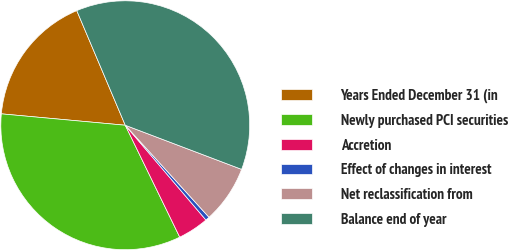Convert chart to OTSL. <chart><loc_0><loc_0><loc_500><loc_500><pie_chart><fcel>Years Ended December 31 (in<fcel>Newly purchased PCI securities<fcel>Accretion<fcel>Effect of changes in interest<fcel>Net reclassification from<fcel>Balance end of year<nl><fcel>17.17%<fcel>33.67%<fcel>4.01%<fcel>0.53%<fcel>7.48%<fcel>37.14%<nl></chart> 